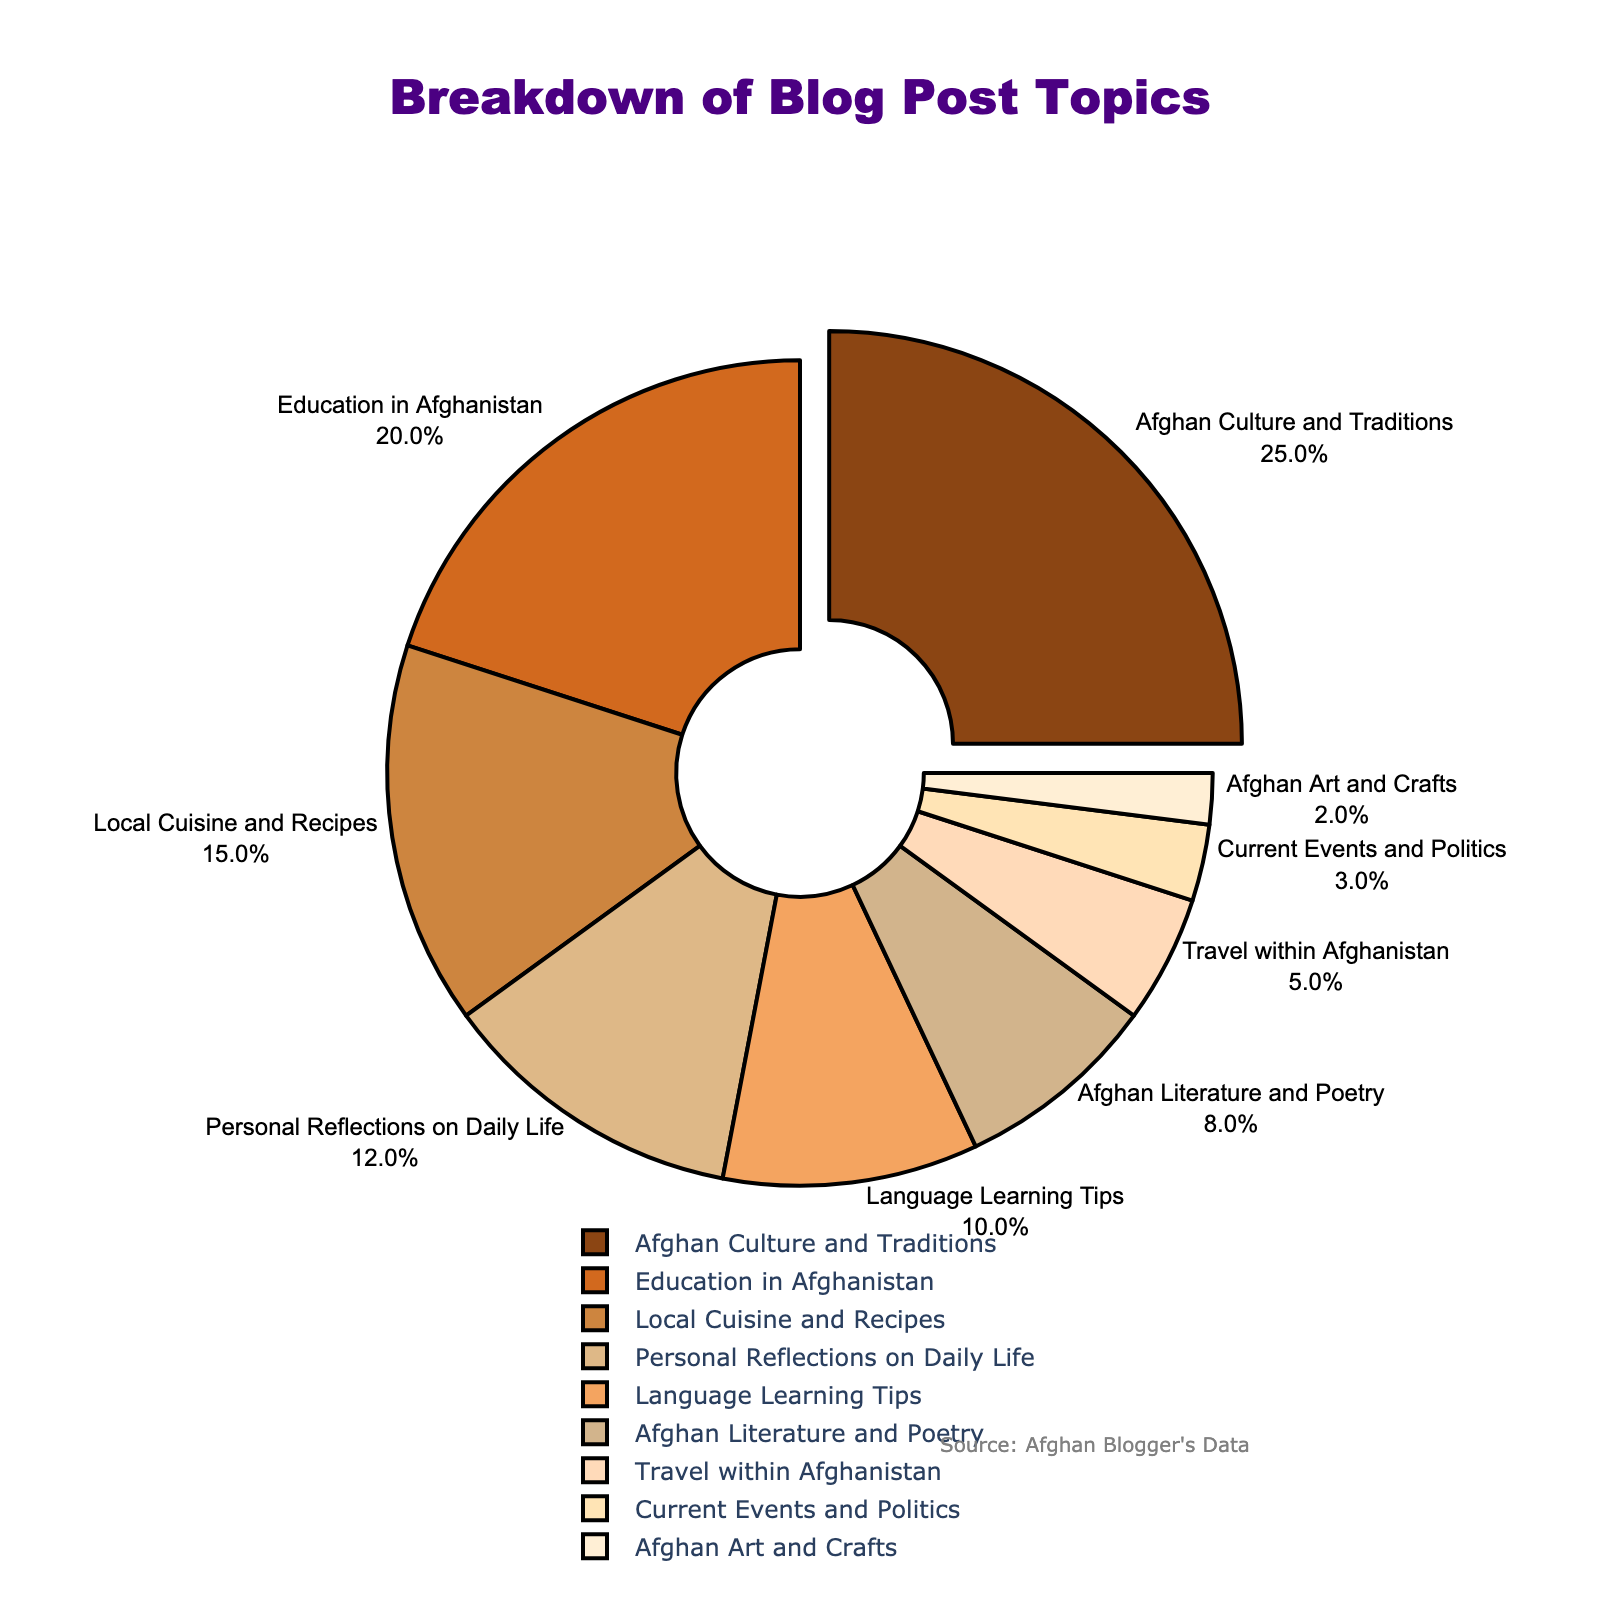What's the most discussed topic on the blog? The "Afghan Culture and Traditions" category occupies the largest part of the pie chart, with 25%. This makes it the most discussed topic.
Answer: Afghan Culture and Traditions Which two categories combined make up more than one-third of the blog topics? The categories "Afghan Culture and Traditions" (25%) and "Education in Afghanistan" (20%) add up to 45%, which is more than one-third (33.33%) of the blog topics.
Answer: Afghan Culture and Traditions and Education in Afghanistan Which topic has twice the percentage of "Local Cuisine and Recipes"? The "Afghan Culture and Traditions" category has 25%, which is twice the 15% of "Local Cuisine and Recipes."
Answer: Afghan Culture and Traditions What is the difference in percentage between "Language Learning Tips" and "Travel within Afghanistan"? "Language Learning Tips" accounts for 10%, while "Travel within Afghanistan" is 5%. The difference is 10% - 5% = 5%.
Answer: 5% How many categories have a percentage less than "Personal Reflections on Daily Life"? "Personal Reflections on Daily Life" has 12%. The categories with a lower percentage are: "Language Learning Tips" (10%), "Afghan Literature and Poetry" (8%), "Travel within Afghanistan" (5%), "Current Events and Politics" (3%), and "Afghan Art and Crafts" (2%). That's 5 categories in total.
Answer: 5 Which category has the smallest share in the pie chart and what is its percentage? "Afghan Art and Crafts" has the smallest share in the pie chart with a percentage of 2%.
Answer: Afghan Art and Crafts, 2% How much larger is the "Education in Afghanistan" category compared to "Afghan Literature and Poetry"? "Education in Afghanistan" is 20%, and "Afghan Literature and Poetry" is 8%. The difference is 20% - 8% = 12%.
Answer: 12% What percentage of the blog is dedicated to personal topics ("Personal Reflections on Daily Life" and "Language Learning Tips")? "Personal Reflections on Daily Life" is 12% and "Language Learning Tips" is 10%. Combined, they account for 12% + 10% = 22%.
Answer: 22% Which category is highlighted or 'pulled out' and why? The "Afghan Culture and Traditions" category is pulled out to emphasize it as the largest segment with 25%.
Answer: Afghan Culture and Traditions 